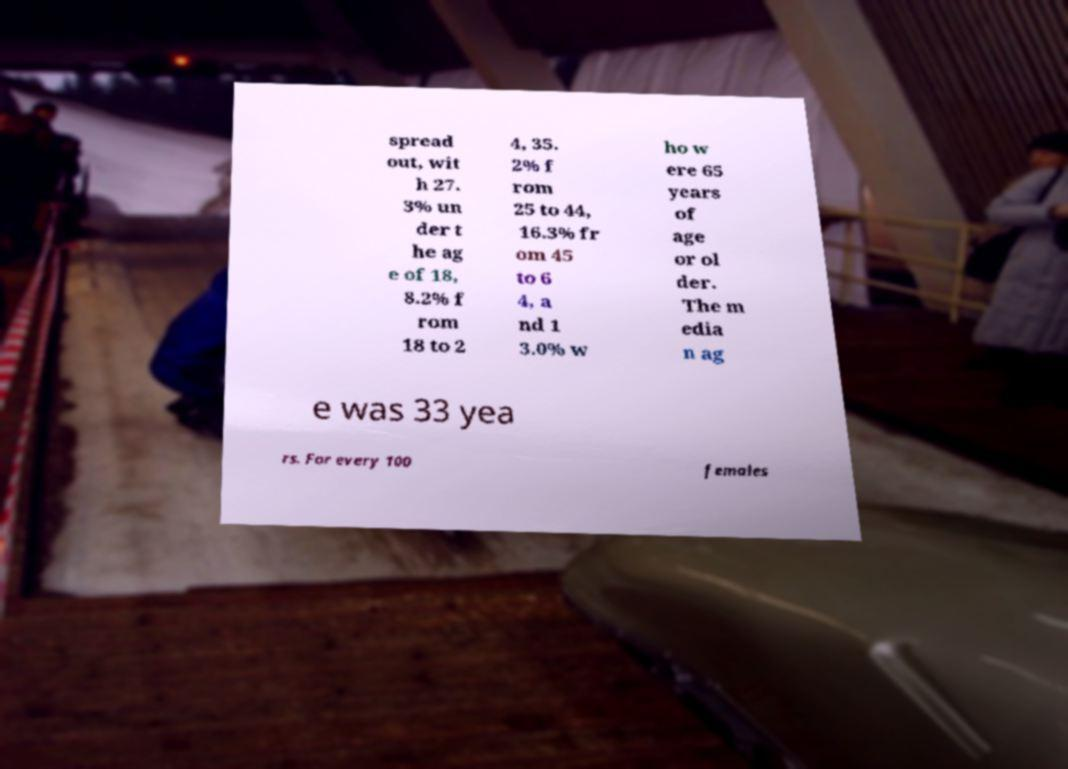Could you extract and type out the text from this image? spread out, wit h 27. 3% un der t he ag e of 18, 8.2% f rom 18 to 2 4, 35. 2% f rom 25 to 44, 16.3% fr om 45 to 6 4, a nd 1 3.0% w ho w ere 65 years of age or ol der. The m edia n ag e was 33 yea rs. For every 100 females 